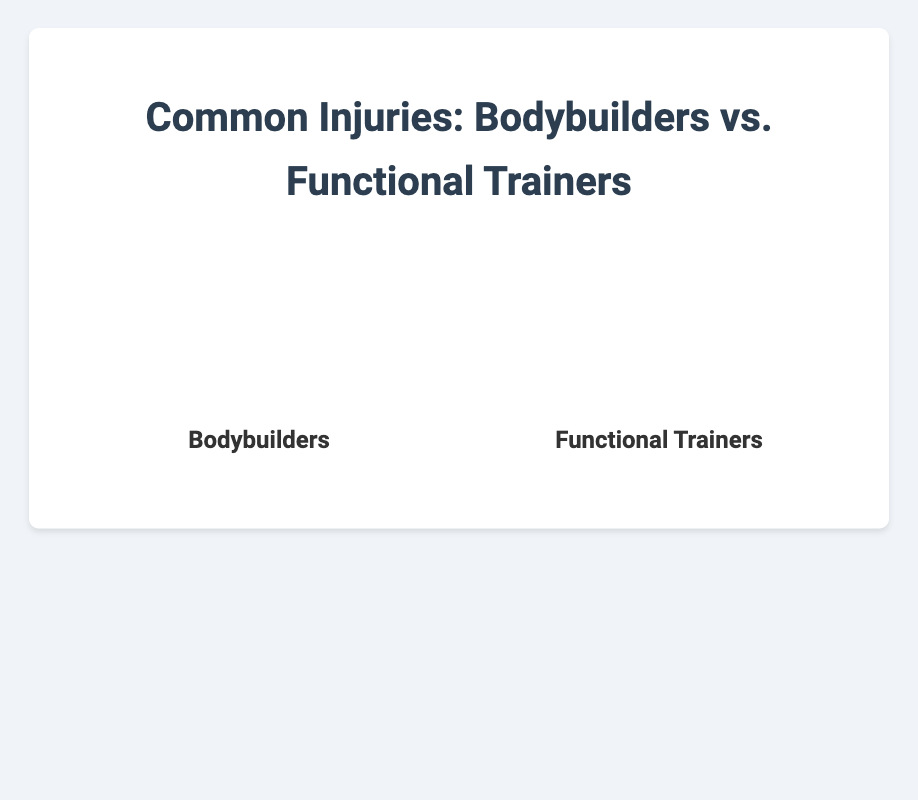Which injury is most common among bodybuilders? The largest portion of the pie chart for bodybuilders is labeled "Muscle Strains," indicating it is the most common injury.
Answer: Muscle Strains Which injury is most common among functional trainers? The largest portion of the pie chart for functional trainers is labeled "Ligament Injuries," indicating it is the most common injury.
Answer: Ligament Injuries How does the occurrence of joint pain compare between bodybuilders and functional trainers? Joint Pain constitutes 25% of injuries in bodybuilders and 20% of injuries in functional trainers.
Answer: More common in bodybuilders Which type of injury is more prevalent among functional trainers than bodybuilders? Ligament Injuries have a higher percentage in functional trainers (35%) compared to bodybuilders (10%).
Answer: Ligament Injuries What is the combined percentage for back pain and tendonitis injuries among bodybuilders? For bodybuilders, Back Pain is 20% and Tendonitis is 15%. Combining them: 20% + 15% = 35%.
Answer: 35% In which group is muscle strain reported less frequently? Muscle Strains in functional trainers are reported at 20%, whereas in bodybuilders it is 30%.
Answer: Functional trainers What is the percentage difference in tendonitis injuries between the two groups? Bodybuilders report 15% for Tendonitis, while functional trainers report 10%. The difference is 15% - 10% = 5%.
Answer: 5% Which group has a higher percentage of back pain? Bodybuilders have 20% Back Pain, while functional trainers have 15%.
Answer: Bodybuilders What percentage of injuries are accounted for by joint pain and muscle strains among functional trainers? Joint Pain and Muscle Strains both account for 20% each. So, 20% + 20% = 40%.
Answer: 40% Which injury has the smallest occurrence among bodybuilders? The smallest portion of the pie chart for bodybuilders is labeled "Ligament Injuries," which is 10%.
Answer: Ligament Injuries 